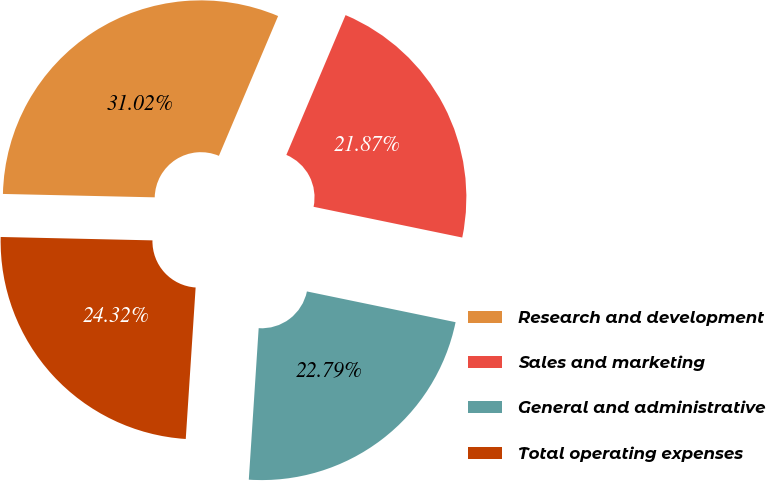<chart> <loc_0><loc_0><loc_500><loc_500><pie_chart><fcel>Research and development<fcel>Sales and marketing<fcel>General and administrative<fcel>Total operating expenses<nl><fcel>31.02%<fcel>21.87%<fcel>22.79%<fcel>24.32%<nl></chart> 